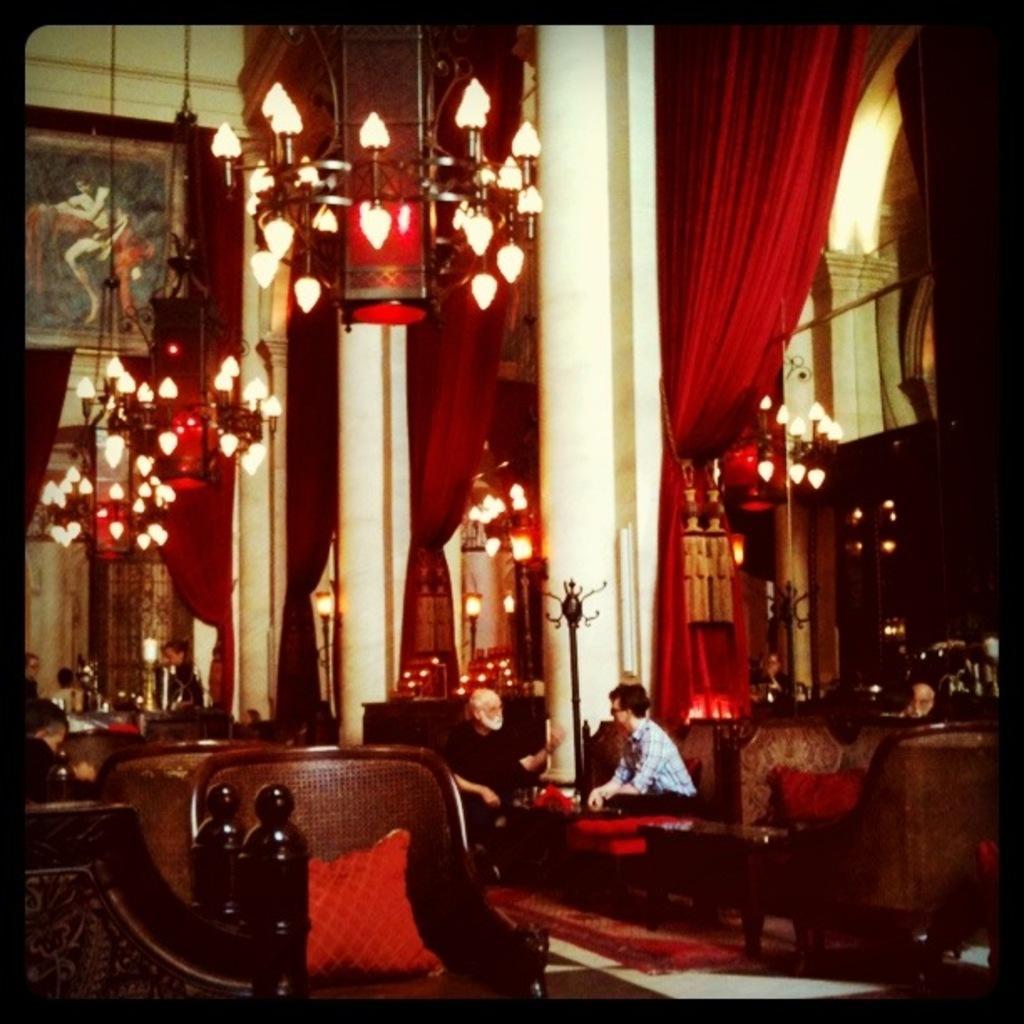Describe this image in one or two sentences. In this image I can see the inner part of the building. I can see few lights, few chairs, couches, red color curtains, pillows, pillars and few people are sitting on the couches. The frame is attached to the wall. 